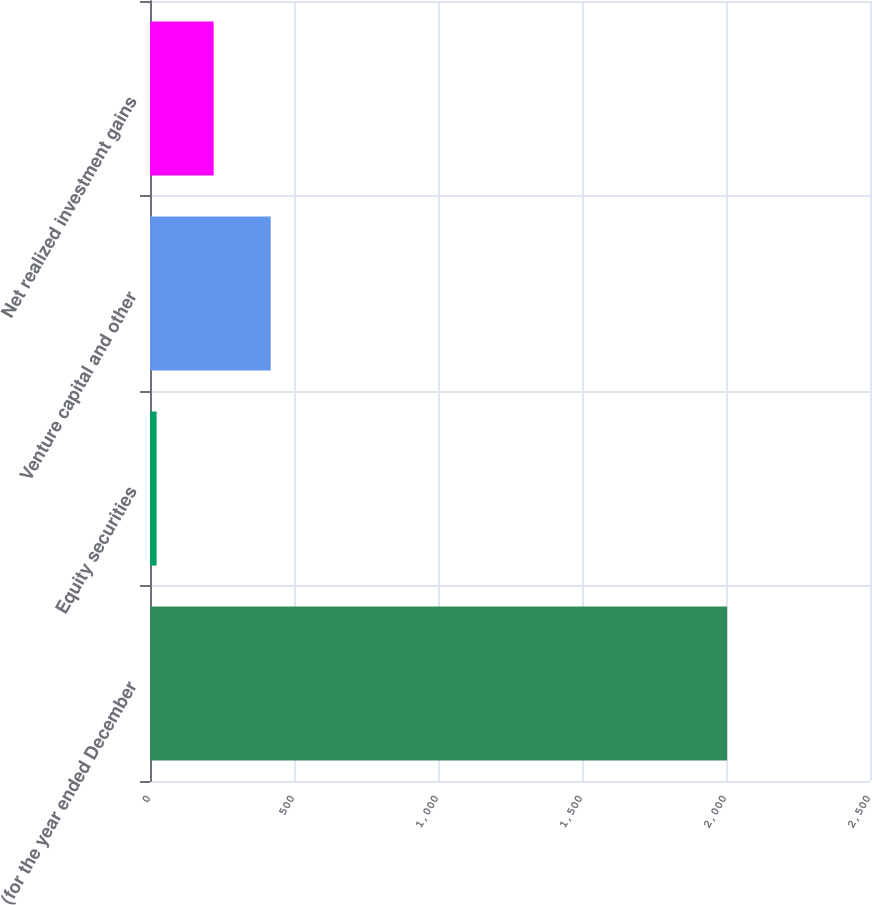Convert chart to OTSL. <chart><loc_0><loc_0><loc_500><loc_500><bar_chart><fcel>(for the year ended December<fcel>Equity securities<fcel>Venture capital and other<fcel>Net realized investment gains<nl><fcel>2004<fcel>23<fcel>419.2<fcel>221.1<nl></chart> 